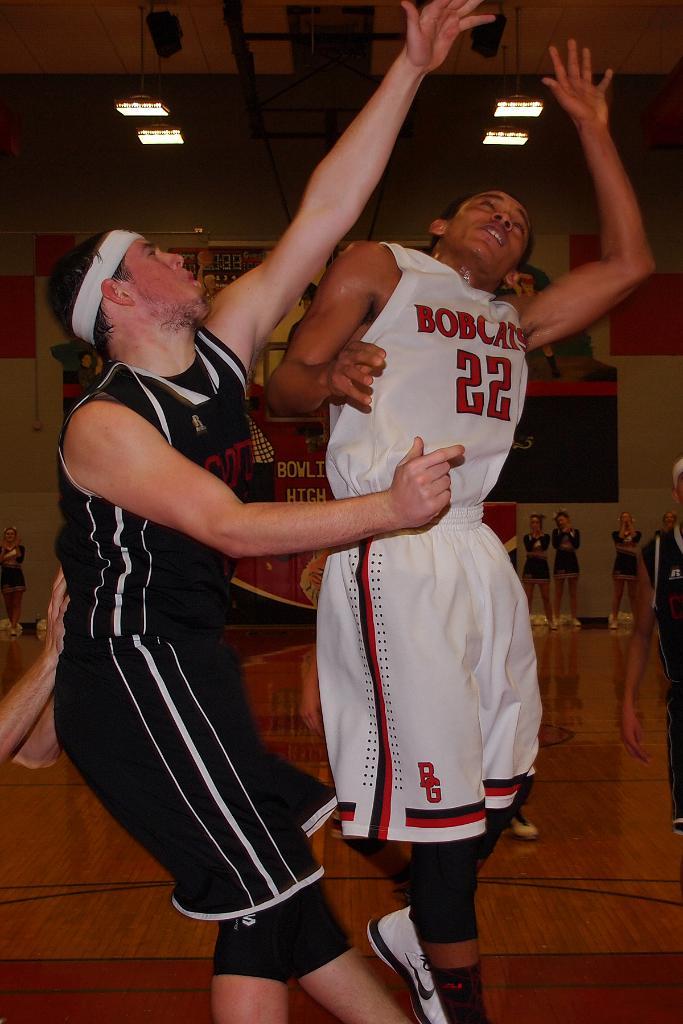What is the number on the white jersey?
Ensure brevity in your answer.  22. 